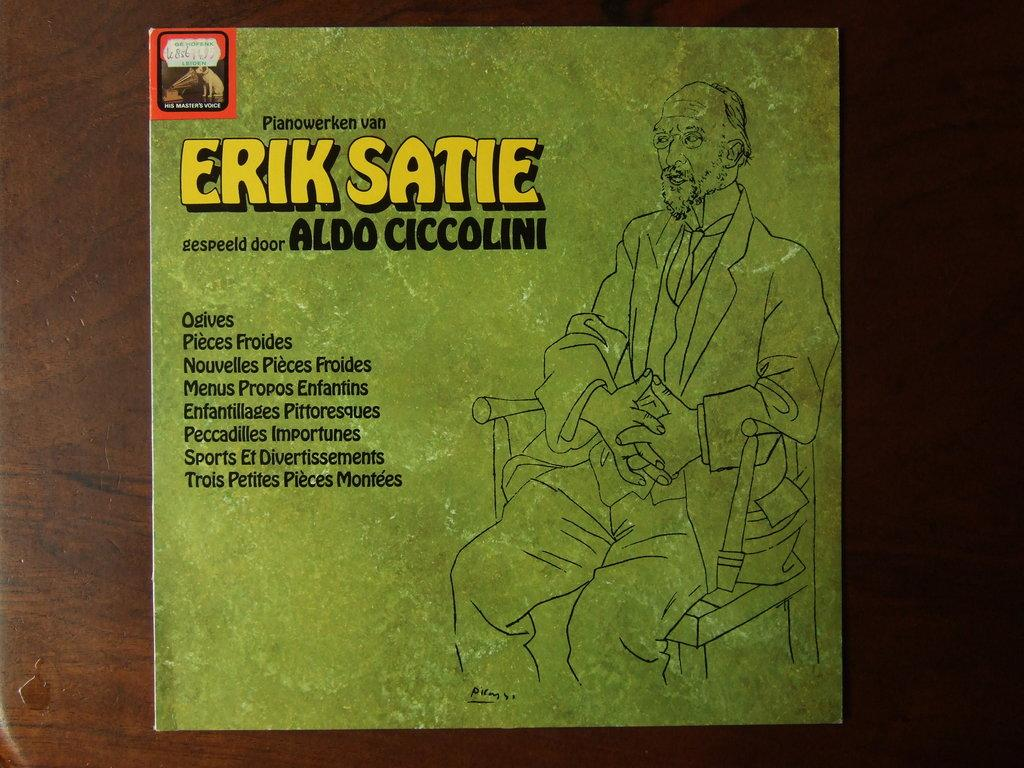<image>
Present a compact description of the photo's key features. An album is entitled "ERIK SATIE" and is green. 